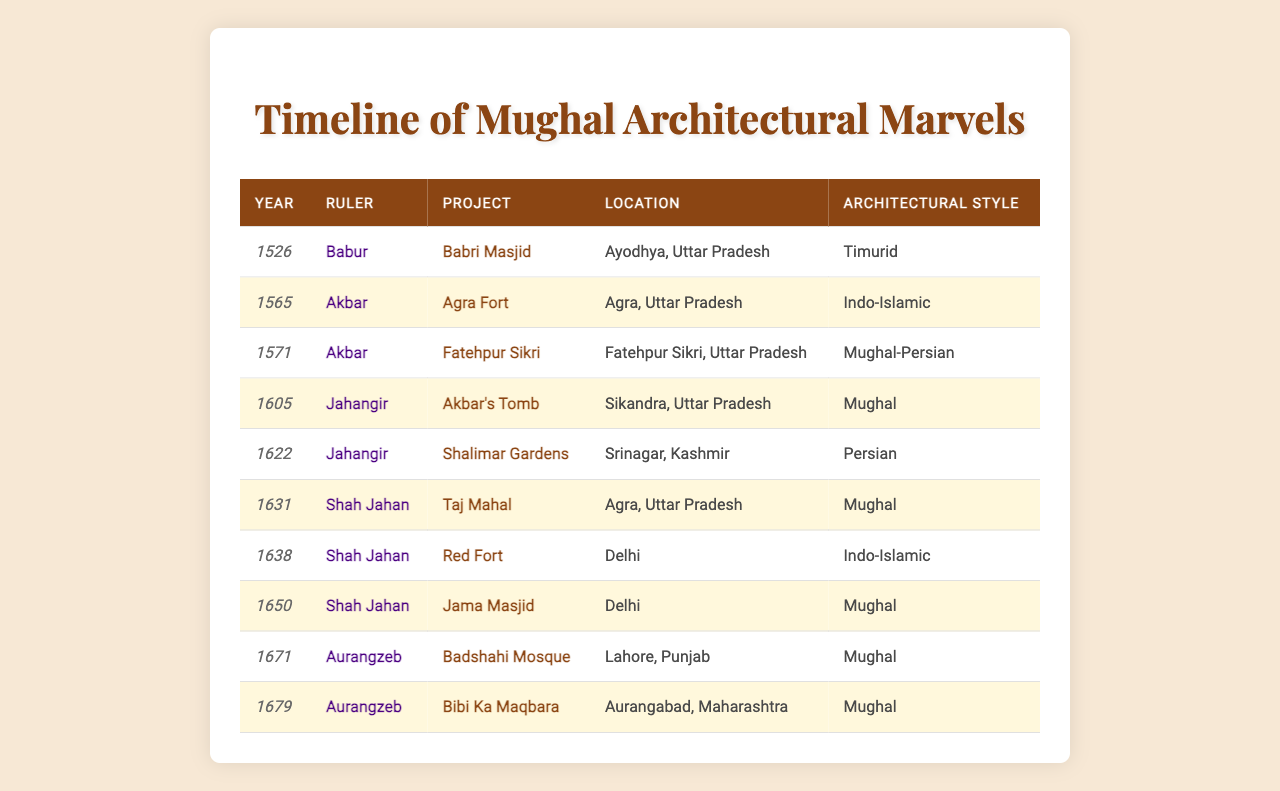What is the most recent architectural project commissioned by a Mughal ruler? The table shows the years of various projects along with their details. The most recent year listed is 1679, which corresponds to the "Bibi Ka Maqbara" commissioned by Aurangzeb.
Answer: Bibi Ka Maqbara Which Mughal ruler commissioned the Taj Mahal? According to the table, the Taj Mahal was commissioned in 1631 by Shah Jahan.
Answer: Shah Jahan How many architectural projects were commissioned during Akbar's reign? By counting the entries for Akbar in the table, we find that there are two projects: Agra Fort and Fatehpur Sikri.
Answer: Two Which architectural style is most frequently represented in the table? Looking at the projects listed in the table, we see that the "Mughal" architectural style appears four times (Taj Mahal, Akbar's Tomb, Jama Masjid, Badshahi Mosque, and Bibi Ka Maqbara). This is more frequent than any other style.
Answer: Mughal Did Aurangzeb commission any architectural projects in his reign? Yes, the table indicates that Aurangzeb commissioned the Badshahi Mosque in 1671 and Bibi Ka Maqbara in 1679.
Answer: Yes How many projects were built in Agra? There are two projects listed in the table that are located in Agra: Agra Fort in 1565 and the Taj Mahal in 1631.
Answer: Two What is the difference in years between the construction of the Red Fort and the Jama Masjid? The Red Fort was commissioned in 1638 and the Jama Masjid in 1650. The difference is 1650 - 1638 = 12 years.
Answer: 12 years Which ruler's projects are located in Delhi? The table shows that Shah Jahan commissioned both the Red Fort in 1638 and the Jama Masjid in 1650 in Delhi.
Answer: Shah Jahan Was the Agra Fort built before the Fatehpur Sikri? Yes, the Agra Fort was constructed in 1565, while Fatehpur Sikri was commissioned later in 1571.
Answer: Yes From the data in the table, what percentage of projects were commissioned by Shah Jahan? There are a total of 10 projects listed, with 5 commissioned by Shah Jahan. The percentage is (5/10)*100 = 50%.
Answer: 50% 